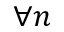<formula> <loc_0><loc_0><loc_500><loc_500>\forall n</formula> 